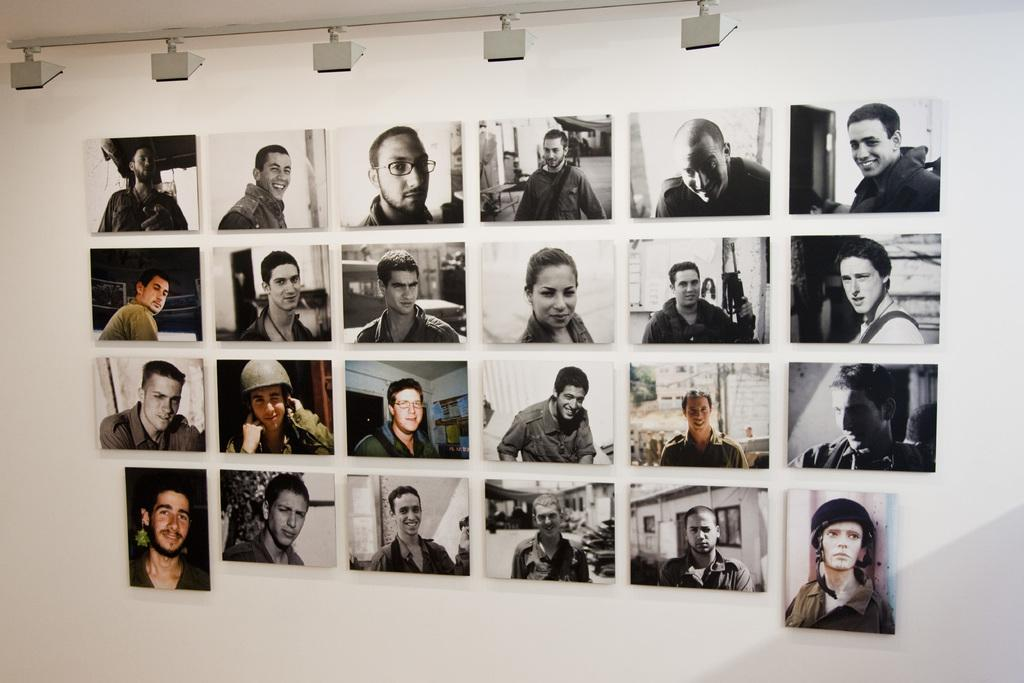What is present on the wall in the image? There are photo frames of different people on the wall. What else can be seen on the wall in the image? There are lights at the top of the wall. Can you see any waves crashing on the shore in the image? There are no waves or shore visible in the image; it features a wall with photo frames and lights. 